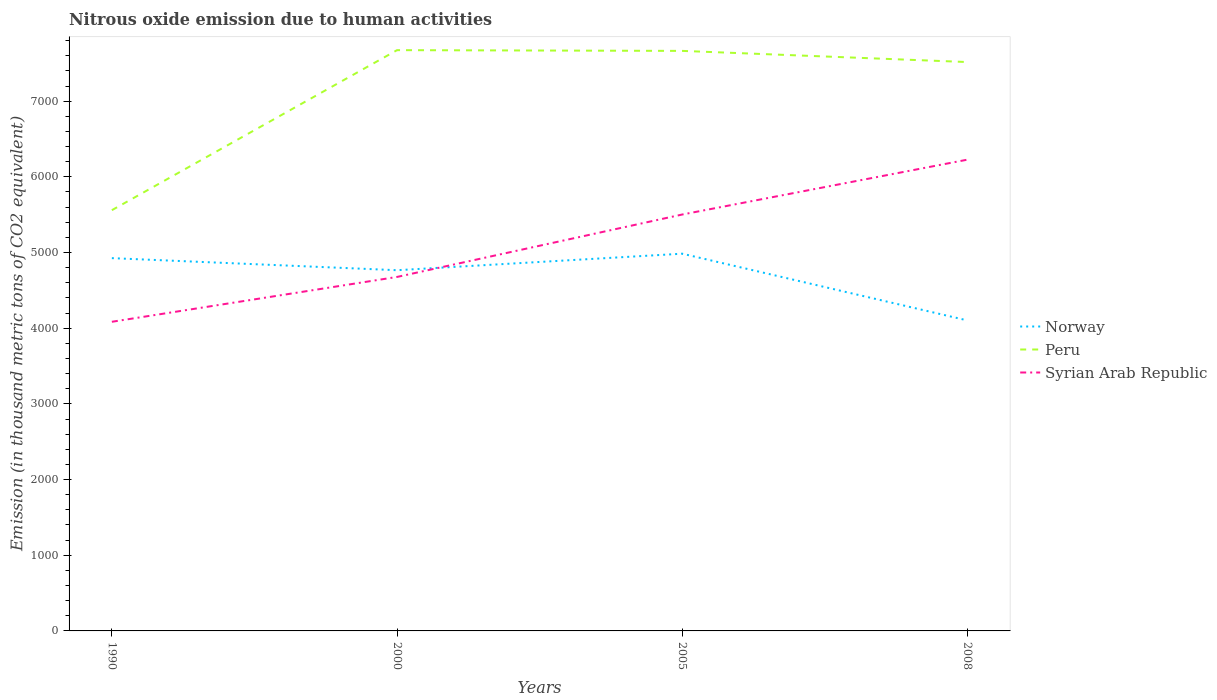Across all years, what is the maximum amount of nitrous oxide emitted in Peru?
Give a very brief answer. 5559.3. What is the total amount of nitrous oxide emitted in Syrian Arab Republic in the graph?
Provide a succinct answer. -724.9. What is the difference between the highest and the second highest amount of nitrous oxide emitted in Norway?
Offer a very short reply. 881.8. What is the difference between the highest and the lowest amount of nitrous oxide emitted in Syrian Arab Republic?
Your response must be concise. 2. How many lines are there?
Your answer should be very brief. 3. Are the values on the major ticks of Y-axis written in scientific E-notation?
Keep it short and to the point. No. Does the graph contain grids?
Ensure brevity in your answer.  No. Where does the legend appear in the graph?
Your answer should be compact. Center right. How many legend labels are there?
Your answer should be very brief. 3. What is the title of the graph?
Provide a succinct answer. Nitrous oxide emission due to human activities. Does "Bhutan" appear as one of the legend labels in the graph?
Your answer should be compact. No. What is the label or title of the X-axis?
Offer a very short reply. Years. What is the label or title of the Y-axis?
Offer a very short reply. Emission (in thousand metric tons of CO2 equivalent). What is the Emission (in thousand metric tons of CO2 equivalent) of Norway in 1990?
Make the answer very short. 4925.7. What is the Emission (in thousand metric tons of CO2 equivalent) of Peru in 1990?
Offer a terse response. 5559.3. What is the Emission (in thousand metric tons of CO2 equivalent) of Syrian Arab Republic in 1990?
Your answer should be very brief. 4084.8. What is the Emission (in thousand metric tons of CO2 equivalent) in Norway in 2000?
Provide a succinct answer. 4766.2. What is the Emission (in thousand metric tons of CO2 equivalent) of Peru in 2000?
Offer a terse response. 7673.9. What is the Emission (in thousand metric tons of CO2 equivalent) in Syrian Arab Republic in 2000?
Keep it short and to the point. 4677.3. What is the Emission (in thousand metric tons of CO2 equivalent) in Norway in 2005?
Offer a terse response. 4984.5. What is the Emission (in thousand metric tons of CO2 equivalent) in Peru in 2005?
Your answer should be very brief. 7664.2. What is the Emission (in thousand metric tons of CO2 equivalent) of Syrian Arab Republic in 2005?
Your answer should be compact. 5502.2. What is the Emission (in thousand metric tons of CO2 equivalent) of Norway in 2008?
Your answer should be compact. 4102.7. What is the Emission (in thousand metric tons of CO2 equivalent) in Peru in 2008?
Make the answer very short. 7516.8. What is the Emission (in thousand metric tons of CO2 equivalent) of Syrian Arab Republic in 2008?
Your answer should be compact. 6227.1. Across all years, what is the maximum Emission (in thousand metric tons of CO2 equivalent) in Norway?
Provide a succinct answer. 4984.5. Across all years, what is the maximum Emission (in thousand metric tons of CO2 equivalent) of Peru?
Provide a short and direct response. 7673.9. Across all years, what is the maximum Emission (in thousand metric tons of CO2 equivalent) of Syrian Arab Republic?
Offer a terse response. 6227.1. Across all years, what is the minimum Emission (in thousand metric tons of CO2 equivalent) of Norway?
Keep it short and to the point. 4102.7. Across all years, what is the minimum Emission (in thousand metric tons of CO2 equivalent) in Peru?
Provide a short and direct response. 5559.3. Across all years, what is the minimum Emission (in thousand metric tons of CO2 equivalent) of Syrian Arab Republic?
Offer a terse response. 4084.8. What is the total Emission (in thousand metric tons of CO2 equivalent) in Norway in the graph?
Provide a short and direct response. 1.88e+04. What is the total Emission (in thousand metric tons of CO2 equivalent) in Peru in the graph?
Ensure brevity in your answer.  2.84e+04. What is the total Emission (in thousand metric tons of CO2 equivalent) in Syrian Arab Republic in the graph?
Your answer should be very brief. 2.05e+04. What is the difference between the Emission (in thousand metric tons of CO2 equivalent) in Norway in 1990 and that in 2000?
Keep it short and to the point. 159.5. What is the difference between the Emission (in thousand metric tons of CO2 equivalent) of Peru in 1990 and that in 2000?
Give a very brief answer. -2114.6. What is the difference between the Emission (in thousand metric tons of CO2 equivalent) of Syrian Arab Republic in 1990 and that in 2000?
Offer a terse response. -592.5. What is the difference between the Emission (in thousand metric tons of CO2 equivalent) of Norway in 1990 and that in 2005?
Your answer should be compact. -58.8. What is the difference between the Emission (in thousand metric tons of CO2 equivalent) of Peru in 1990 and that in 2005?
Give a very brief answer. -2104.9. What is the difference between the Emission (in thousand metric tons of CO2 equivalent) of Syrian Arab Republic in 1990 and that in 2005?
Give a very brief answer. -1417.4. What is the difference between the Emission (in thousand metric tons of CO2 equivalent) in Norway in 1990 and that in 2008?
Your answer should be compact. 823. What is the difference between the Emission (in thousand metric tons of CO2 equivalent) of Peru in 1990 and that in 2008?
Keep it short and to the point. -1957.5. What is the difference between the Emission (in thousand metric tons of CO2 equivalent) of Syrian Arab Republic in 1990 and that in 2008?
Make the answer very short. -2142.3. What is the difference between the Emission (in thousand metric tons of CO2 equivalent) in Norway in 2000 and that in 2005?
Offer a very short reply. -218.3. What is the difference between the Emission (in thousand metric tons of CO2 equivalent) in Syrian Arab Republic in 2000 and that in 2005?
Your answer should be compact. -824.9. What is the difference between the Emission (in thousand metric tons of CO2 equivalent) of Norway in 2000 and that in 2008?
Make the answer very short. 663.5. What is the difference between the Emission (in thousand metric tons of CO2 equivalent) in Peru in 2000 and that in 2008?
Keep it short and to the point. 157.1. What is the difference between the Emission (in thousand metric tons of CO2 equivalent) in Syrian Arab Republic in 2000 and that in 2008?
Your answer should be very brief. -1549.8. What is the difference between the Emission (in thousand metric tons of CO2 equivalent) in Norway in 2005 and that in 2008?
Offer a very short reply. 881.8. What is the difference between the Emission (in thousand metric tons of CO2 equivalent) in Peru in 2005 and that in 2008?
Ensure brevity in your answer.  147.4. What is the difference between the Emission (in thousand metric tons of CO2 equivalent) in Syrian Arab Republic in 2005 and that in 2008?
Give a very brief answer. -724.9. What is the difference between the Emission (in thousand metric tons of CO2 equivalent) in Norway in 1990 and the Emission (in thousand metric tons of CO2 equivalent) in Peru in 2000?
Provide a succinct answer. -2748.2. What is the difference between the Emission (in thousand metric tons of CO2 equivalent) of Norway in 1990 and the Emission (in thousand metric tons of CO2 equivalent) of Syrian Arab Republic in 2000?
Ensure brevity in your answer.  248.4. What is the difference between the Emission (in thousand metric tons of CO2 equivalent) of Peru in 1990 and the Emission (in thousand metric tons of CO2 equivalent) of Syrian Arab Republic in 2000?
Make the answer very short. 882. What is the difference between the Emission (in thousand metric tons of CO2 equivalent) in Norway in 1990 and the Emission (in thousand metric tons of CO2 equivalent) in Peru in 2005?
Offer a terse response. -2738.5. What is the difference between the Emission (in thousand metric tons of CO2 equivalent) in Norway in 1990 and the Emission (in thousand metric tons of CO2 equivalent) in Syrian Arab Republic in 2005?
Give a very brief answer. -576.5. What is the difference between the Emission (in thousand metric tons of CO2 equivalent) in Peru in 1990 and the Emission (in thousand metric tons of CO2 equivalent) in Syrian Arab Republic in 2005?
Ensure brevity in your answer.  57.1. What is the difference between the Emission (in thousand metric tons of CO2 equivalent) of Norway in 1990 and the Emission (in thousand metric tons of CO2 equivalent) of Peru in 2008?
Offer a very short reply. -2591.1. What is the difference between the Emission (in thousand metric tons of CO2 equivalent) in Norway in 1990 and the Emission (in thousand metric tons of CO2 equivalent) in Syrian Arab Republic in 2008?
Your answer should be very brief. -1301.4. What is the difference between the Emission (in thousand metric tons of CO2 equivalent) of Peru in 1990 and the Emission (in thousand metric tons of CO2 equivalent) of Syrian Arab Republic in 2008?
Offer a very short reply. -667.8. What is the difference between the Emission (in thousand metric tons of CO2 equivalent) in Norway in 2000 and the Emission (in thousand metric tons of CO2 equivalent) in Peru in 2005?
Offer a terse response. -2898. What is the difference between the Emission (in thousand metric tons of CO2 equivalent) of Norway in 2000 and the Emission (in thousand metric tons of CO2 equivalent) of Syrian Arab Republic in 2005?
Offer a very short reply. -736. What is the difference between the Emission (in thousand metric tons of CO2 equivalent) of Peru in 2000 and the Emission (in thousand metric tons of CO2 equivalent) of Syrian Arab Republic in 2005?
Provide a succinct answer. 2171.7. What is the difference between the Emission (in thousand metric tons of CO2 equivalent) in Norway in 2000 and the Emission (in thousand metric tons of CO2 equivalent) in Peru in 2008?
Offer a terse response. -2750.6. What is the difference between the Emission (in thousand metric tons of CO2 equivalent) in Norway in 2000 and the Emission (in thousand metric tons of CO2 equivalent) in Syrian Arab Republic in 2008?
Offer a terse response. -1460.9. What is the difference between the Emission (in thousand metric tons of CO2 equivalent) of Peru in 2000 and the Emission (in thousand metric tons of CO2 equivalent) of Syrian Arab Republic in 2008?
Provide a short and direct response. 1446.8. What is the difference between the Emission (in thousand metric tons of CO2 equivalent) of Norway in 2005 and the Emission (in thousand metric tons of CO2 equivalent) of Peru in 2008?
Offer a very short reply. -2532.3. What is the difference between the Emission (in thousand metric tons of CO2 equivalent) in Norway in 2005 and the Emission (in thousand metric tons of CO2 equivalent) in Syrian Arab Republic in 2008?
Offer a terse response. -1242.6. What is the difference between the Emission (in thousand metric tons of CO2 equivalent) of Peru in 2005 and the Emission (in thousand metric tons of CO2 equivalent) of Syrian Arab Republic in 2008?
Ensure brevity in your answer.  1437.1. What is the average Emission (in thousand metric tons of CO2 equivalent) of Norway per year?
Make the answer very short. 4694.77. What is the average Emission (in thousand metric tons of CO2 equivalent) in Peru per year?
Your answer should be very brief. 7103.55. What is the average Emission (in thousand metric tons of CO2 equivalent) in Syrian Arab Republic per year?
Your response must be concise. 5122.85. In the year 1990, what is the difference between the Emission (in thousand metric tons of CO2 equivalent) in Norway and Emission (in thousand metric tons of CO2 equivalent) in Peru?
Provide a short and direct response. -633.6. In the year 1990, what is the difference between the Emission (in thousand metric tons of CO2 equivalent) of Norway and Emission (in thousand metric tons of CO2 equivalent) of Syrian Arab Republic?
Give a very brief answer. 840.9. In the year 1990, what is the difference between the Emission (in thousand metric tons of CO2 equivalent) in Peru and Emission (in thousand metric tons of CO2 equivalent) in Syrian Arab Republic?
Your answer should be very brief. 1474.5. In the year 2000, what is the difference between the Emission (in thousand metric tons of CO2 equivalent) in Norway and Emission (in thousand metric tons of CO2 equivalent) in Peru?
Your answer should be very brief. -2907.7. In the year 2000, what is the difference between the Emission (in thousand metric tons of CO2 equivalent) in Norway and Emission (in thousand metric tons of CO2 equivalent) in Syrian Arab Republic?
Give a very brief answer. 88.9. In the year 2000, what is the difference between the Emission (in thousand metric tons of CO2 equivalent) in Peru and Emission (in thousand metric tons of CO2 equivalent) in Syrian Arab Republic?
Keep it short and to the point. 2996.6. In the year 2005, what is the difference between the Emission (in thousand metric tons of CO2 equivalent) in Norway and Emission (in thousand metric tons of CO2 equivalent) in Peru?
Your answer should be very brief. -2679.7. In the year 2005, what is the difference between the Emission (in thousand metric tons of CO2 equivalent) of Norway and Emission (in thousand metric tons of CO2 equivalent) of Syrian Arab Republic?
Your response must be concise. -517.7. In the year 2005, what is the difference between the Emission (in thousand metric tons of CO2 equivalent) of Peru and Emission (in thousand metric tons of CO2 equivalent) of Syrian Arab Republic?
Make the answer very short. 2162. In the year 2008, what is the difference between the Emission (in thousand metric tons of CO2 equivalent) of Norway and Emission (in thousand metric tons of CO2 equivalent) of Peru?
Your response must be concise. -3414.1. In the year 2008, what is the difference between the Emission (in thousand metric tons of CO2 equivalent) of Norway and Emission (in thousand metric tons of CO2 equivalent) of Syrian Arab Republic?
Offer a terse response. -2124.4. In the year 2008, what is the difference between the Emission (in thousand metric tons of CO2 equivalent) in Peru and Emission (in thousand metric tons of CO2 equivalent) in Syrian Arab Republic?
Keep it short and to the point. 1289.7. What is the ratio of the Emission (in thousand metric tons of CO2 equivalent) of Norway in 1990 to that in 2000?
Your answer should be compact. 1.03. What is the ratio of the Emission (in thousand metric tons of CO2 equivalent) in Peru in 1990 to that in 2000?
Your answer should be compact. 0.72. What is the ratio of the Emission (in thousand metric tons of CO2 equivalent) of Syrian Arab Republic in 1990 to that in 2000?
Give a very brief answer. 0.87. What is the ratio of the Emission (in thousand metric tons of CO2 equivalent) in Peru in 1990 to that in 2005?
Offer a terse response. 0.73. What is the ratio of the Emission (in thousand metric tons of CO2 equivalent) of Syrian Arab Republic in 1990 to that in 2005?
Your response must be concise. 0.74. What is the ratio of the Emission (in thousand metric tons of CO2 equivalent) of Norway in 1990 to that in 2008?
Provide a short and direct response. 1.2. What is the ratio of the Emission (in thousand metric tons of CO2 equivalent) of Peru in 1990 to that in 2008?
Give a very brief answer. 0.74. What is the ratio of the Emission (in thousand metric tons of CO2 equivalent) in Syrian Arab Republic in 1990 to that in 2008?
Offer a very short reply. 0.66. What is the ratio of the Emission (in thousand metric tons of CO2 equivalent) of Norway in 2000 to that in 2005?
Provide a succinct answer. 0.96. What is the ratio of the Emission (in thousand metric tons of CO2 equivalent) in Syrian Arab Republic in 2000 to that in 2005?
Ensure brevity in your answer.  0.85. What is the ratio of the Emission (in thousand metric tons of CO2 equivalent) in Norway in 2000 to that in 2008?
Provide a succinct answer. 1.16. What is the ratio of the Emission (in thousand metric tons of CO2 equivalent) of Peru in 2000 to that in 2008?
Make the answer very short. 1.02. What is the ratio of the Emission (in thousand metric tons of CO2 equivalent) in Syrian Arab Republic in 2000 to that in 2008?
Offer a very short reply. 0.75. What is the ratio of the Emission (in thousand metric tons of CO2 equivalent) in Norway in 2005 to that in 2008?
Your answer should be compact. 1.21. What is the ratio of the Emission (in thousand metric tons of CO2 equivalent) in Peru in 2005 to that in 2008?
Your answer should be compact. 1.02. What is the ratio of the Emission (in thousand metric tons of CO2 equivalent) in Syrian Arab Republic in 2005 to that in 2008?
Make the answer very short. 0.88. What is the difference between the highest and the second highest Emission (in thousand metric tons of CO2 equivalent) in Norway?
Ensure brevity in your answer.  58.8. What is the difference between the highest and the second highest Emission (in thousand metric tons of CO2 equivalent) of Syrian Arab Republic?
Keep it short and to the point. 724.9. What is the difference between the highest and the lowest Emission (in thousand metric tons of CO2 equivalent) of Norway?
Your answer should be compact. 881.8. What is the difference between the highest and the lowest Emission (in thousand metric tons of CO2 equivalent) of Peru?
Provide a succinct answer. 2114.6. What is the difference between the highest and the lowest Emission (in thousand metric tons of CO2 equivalent) in Syrian Arab Republic?
Your response must be concise. 2142.3. 